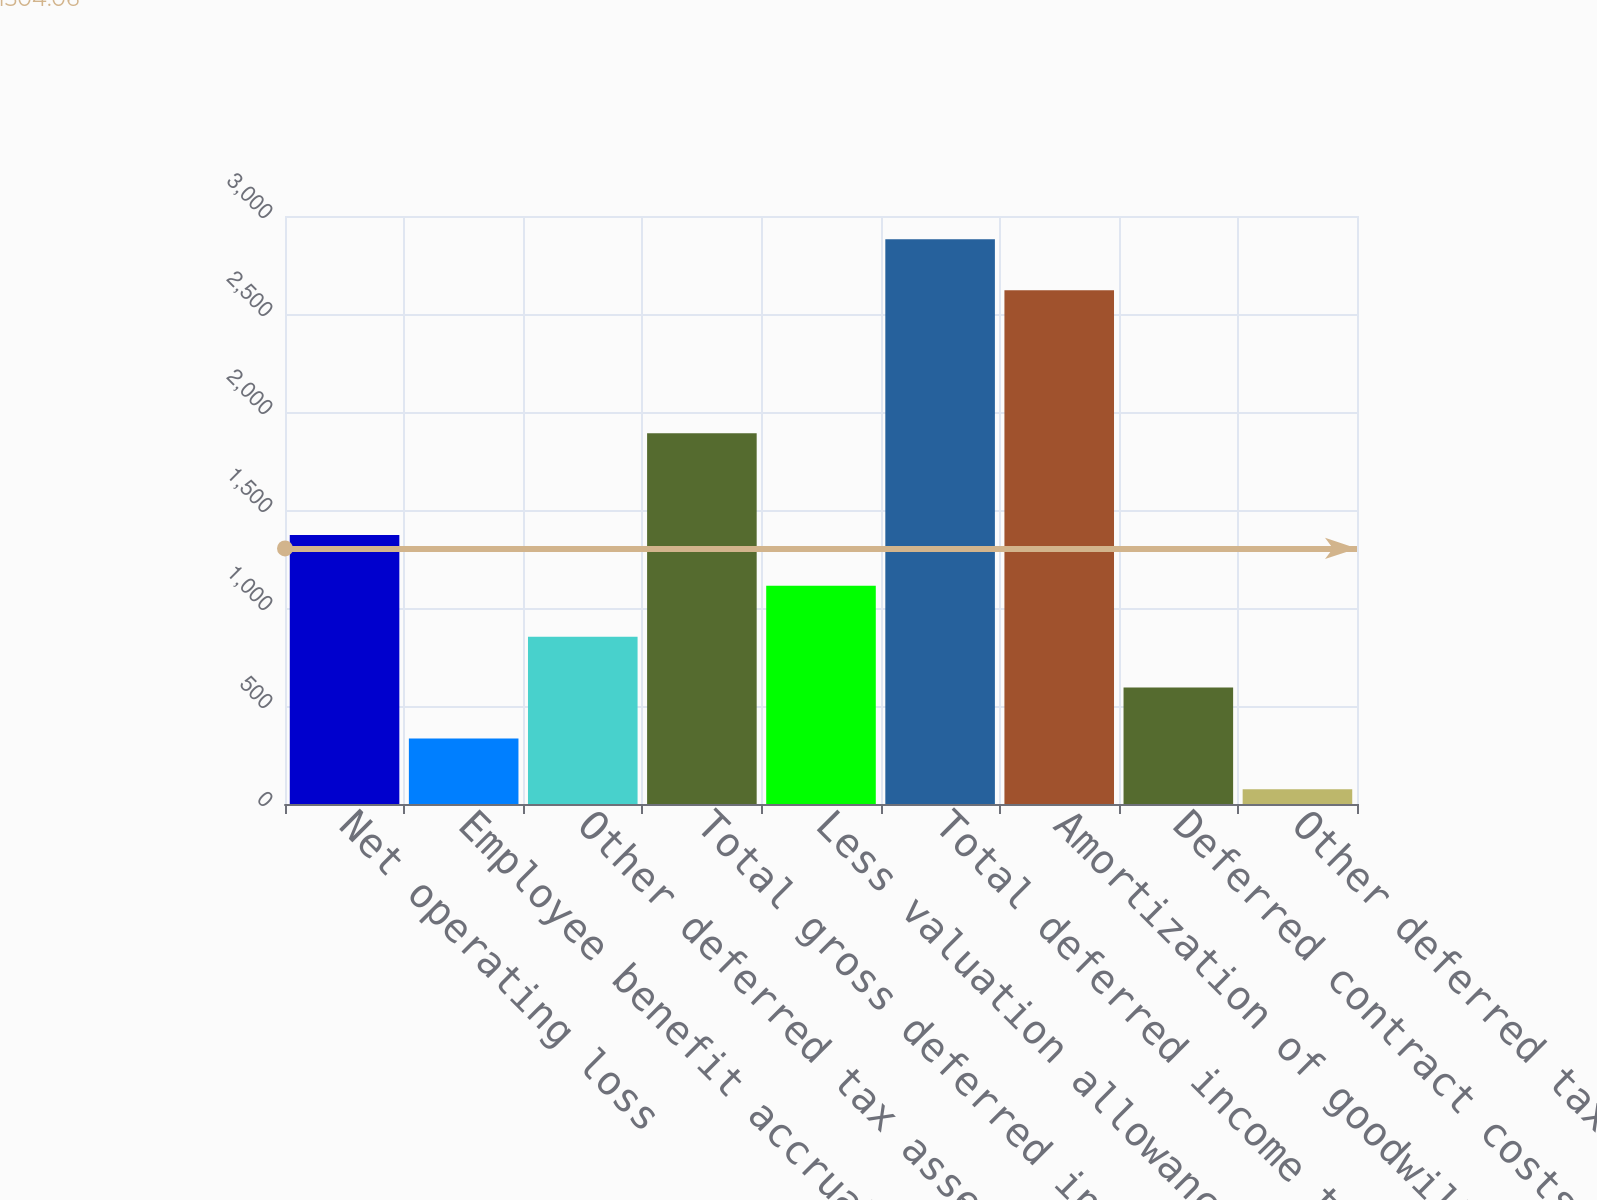Convert chart to OTSL. <chart><loc_0><loc_0><loc_500><loc_500><bar_chart><fcel>Net operating loss<fcel>Employee benefit accruals<fcel>Other deferred tax assets<fcel>Total gross deferred income<fcel>Less valuation allowance<fcel>Total deferred income tax<fcel>Amortization of goodwill and<fcel>Deferred contract costs<fcel>Other deferred tax liabilities<nl><fcel>1372.5<fcel>334.5<fcel>853.5<fcel>1891.5<fcel>1113<fcel>2881<fcel>2621.5<fcel>594<fcel>75<nl></chart> 